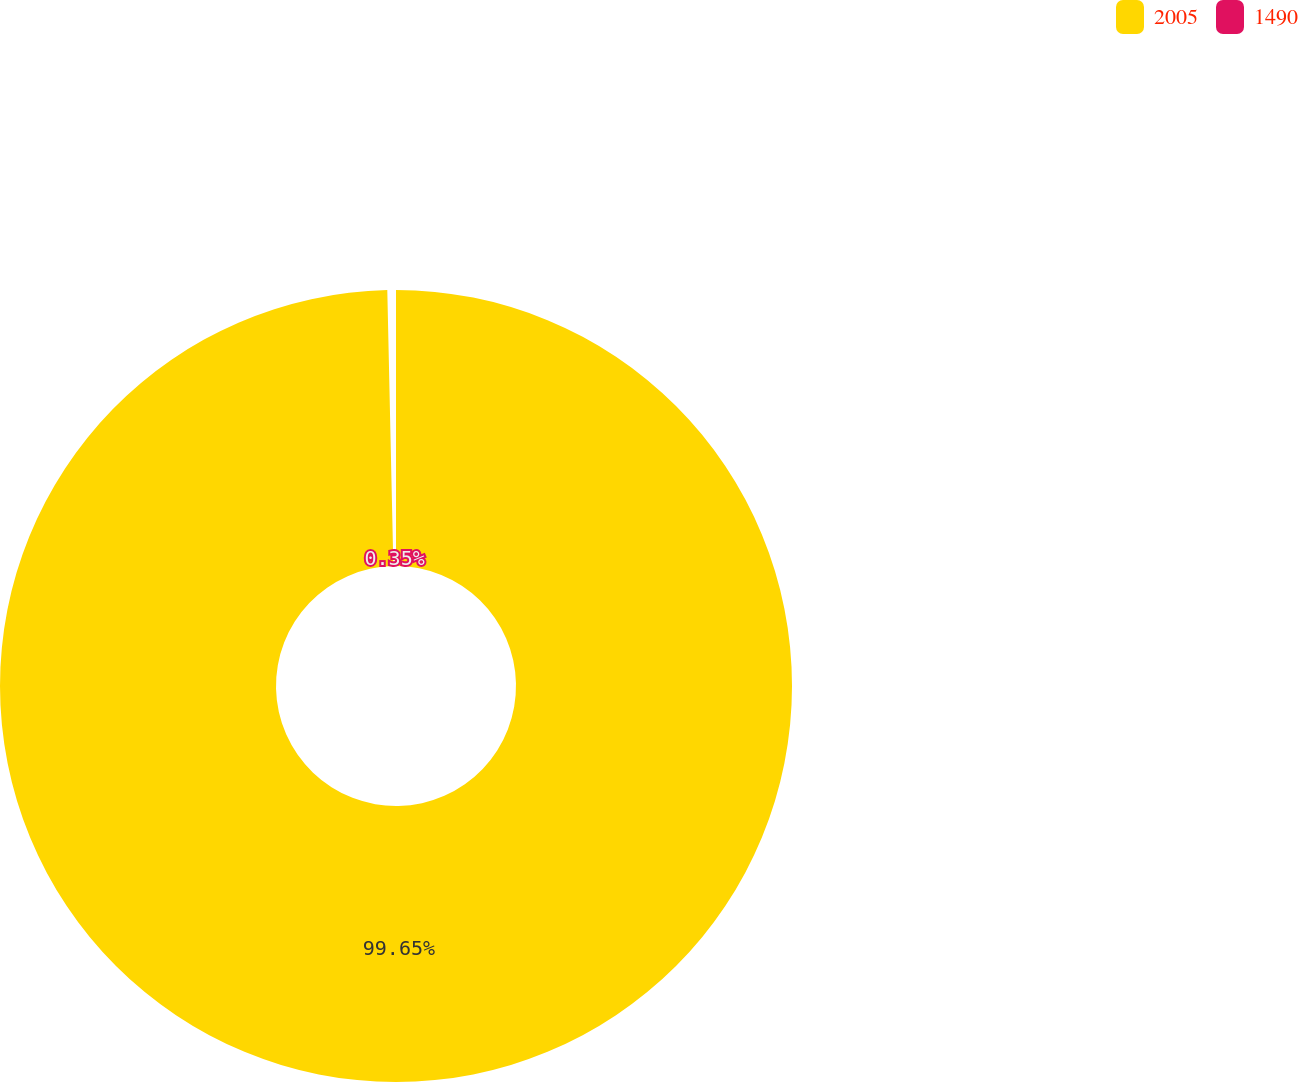<chart> <loc_0><loc_0><loc_500><loc_500><pie_chart><fcel>2005<fcel>1490<nl><fcel>99.65%<fcel>0.35%<nl></chart> 